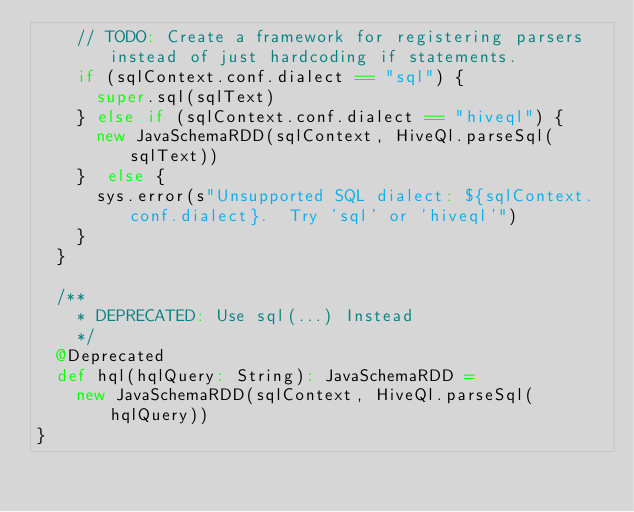<code> <loc_0><loc_0><loc_500><loc_500><_Scala_>    // TODO: Create a framework for registering parsers instead of just hardcoding if statements.
    if (sqlContext.conf.dialect == "sql") {
      super.sql(sqlText)
    } else if (sqlContext.conf.dialect == "hiveql") {
      new JavaSchemaRDD(sqlContext, HiveQl.parseSql(sqlText))
    }  else {
      sys.error(s"Unsupported SQL dialect: ${sqlContext.conf.dialect}.  Try 'sql' or 'hiveql'")
    }
  }

  /**
    * DEPRECATED: Use sql(...) Instead
    */
  @Deprecated
  def hql(hqlQuery: String): JavaSchemaRDD =
    new JavaSchemaRDD(sqlContext, HiveQl.parseSql(hqlQuery))
}
</code> 